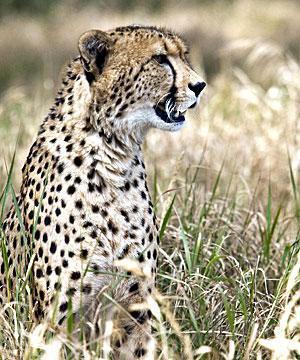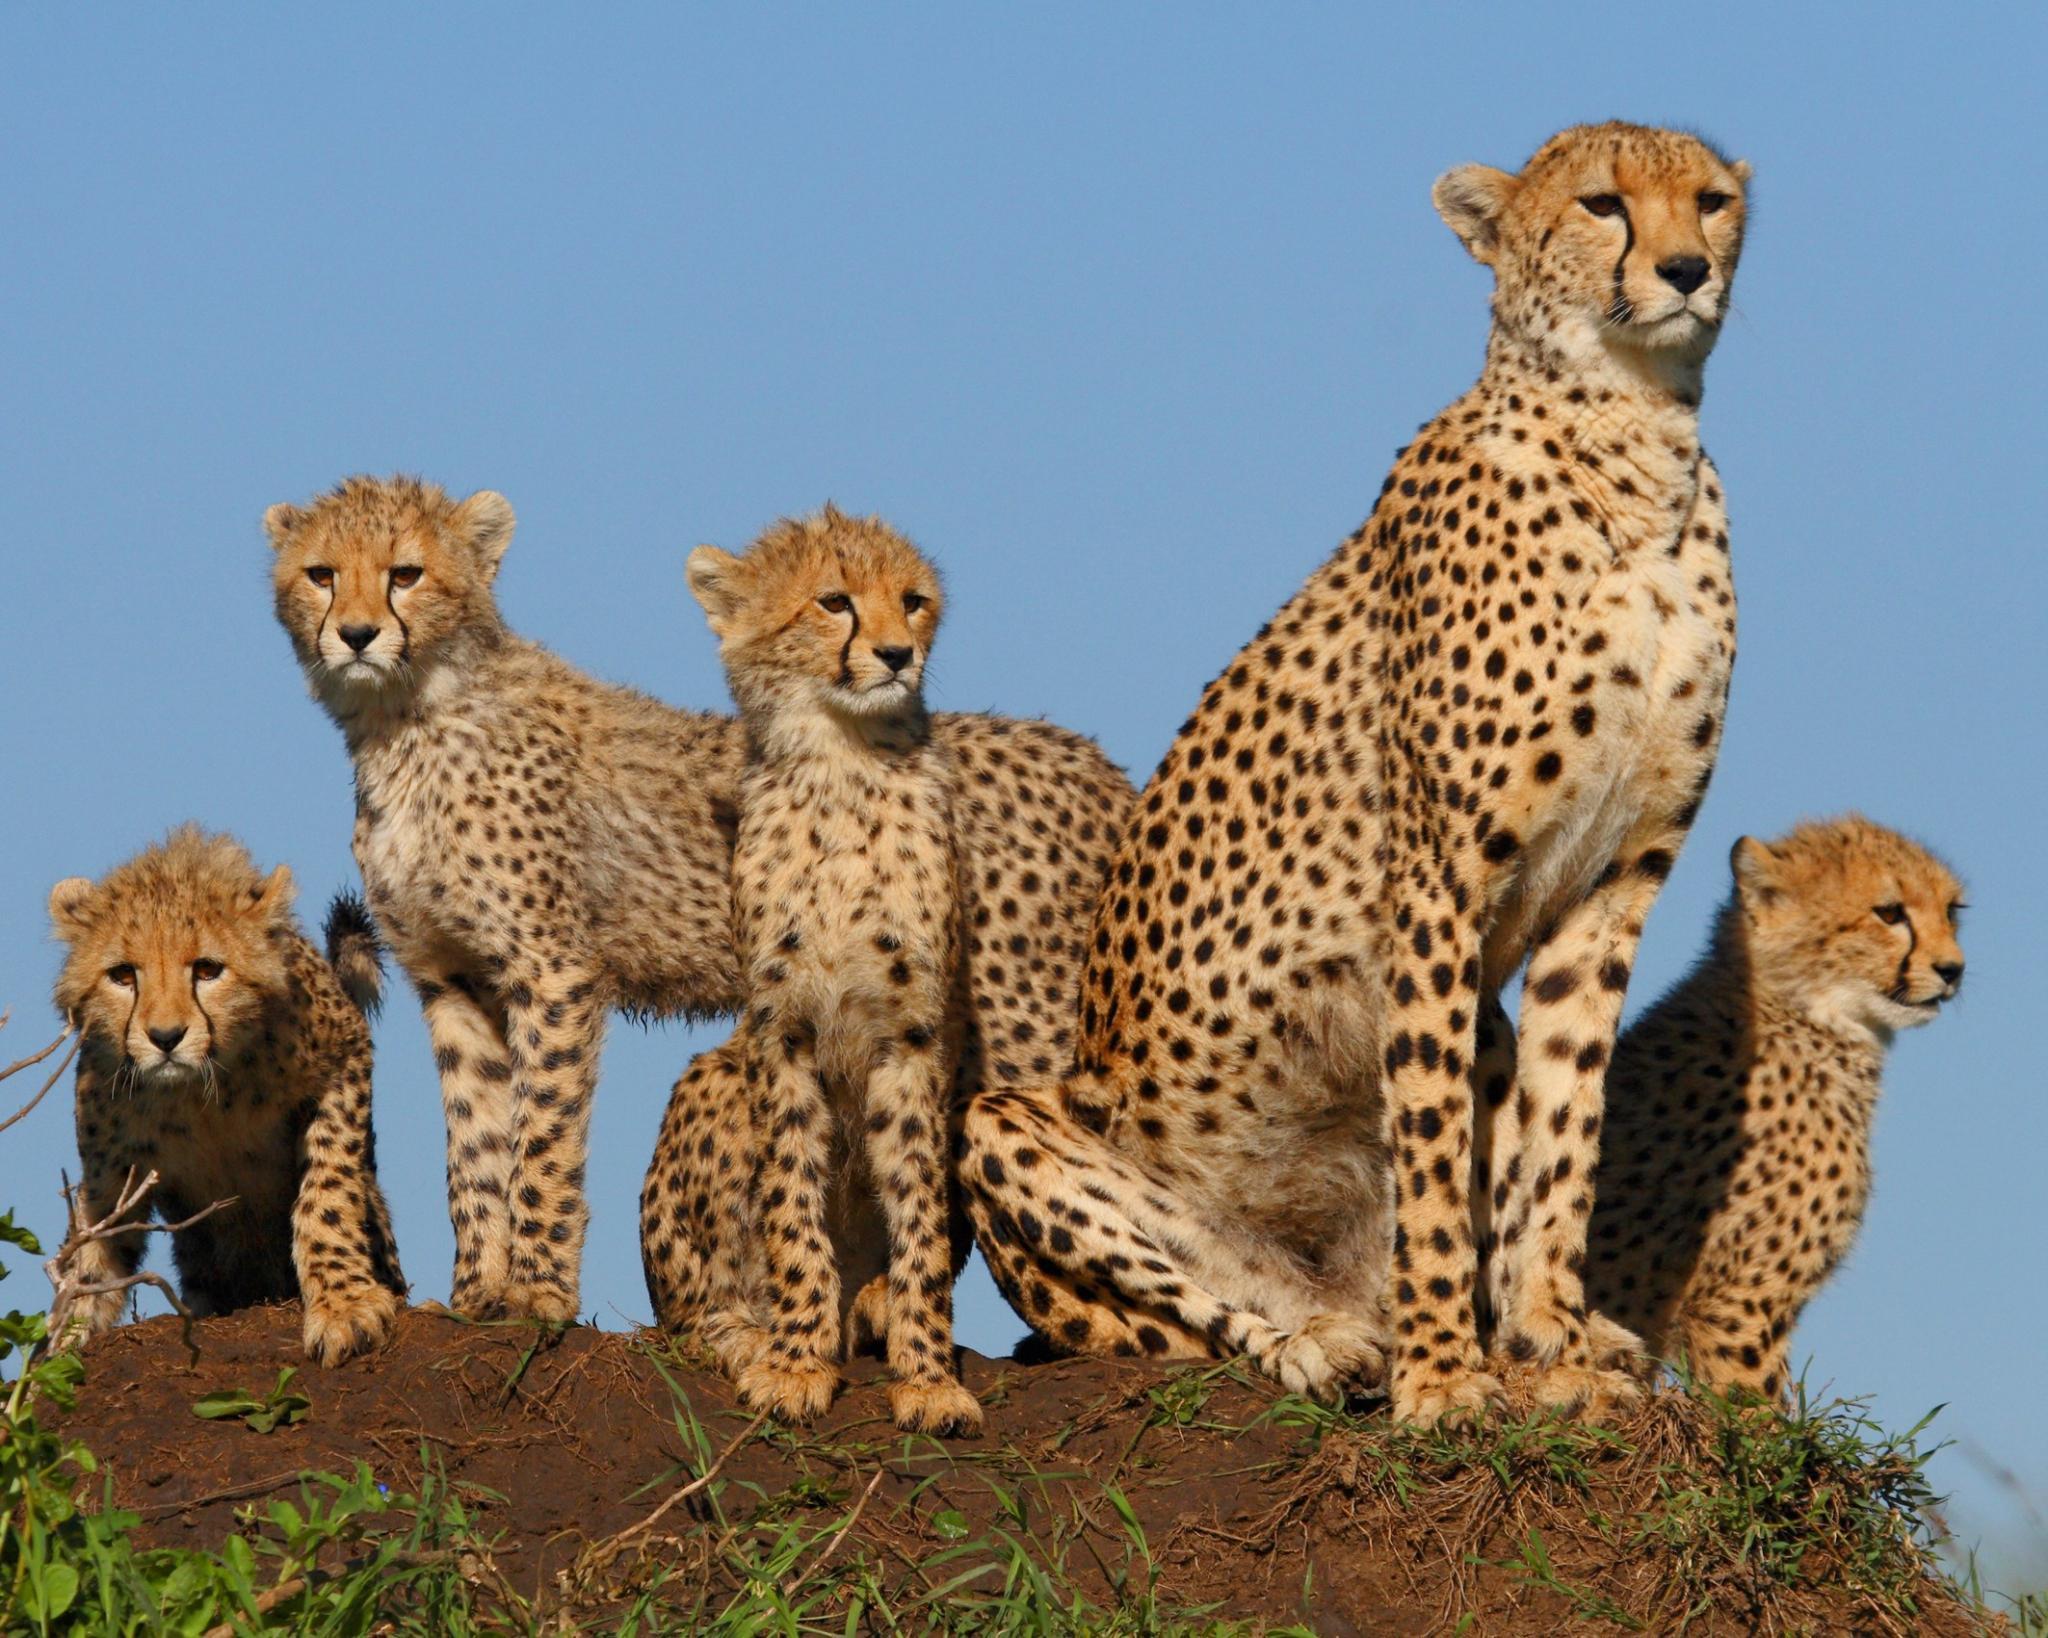The first image is the image on the left, the second image is the image on the right. For the images displayed, is the sentence "Four leopards are laying on a dirt patch in a yellow-green field in one of the images." factually correct? Answer yes or no. No. 